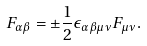<formula> <loc_0><loc_0><loc_500><loc_500>F _ { \alpha \beta } = \pm { \frac { 1 } { 2 } } \epsilon _ { \alpha \beta \mu \nu } F _ { \mu \nu } .</formula> 